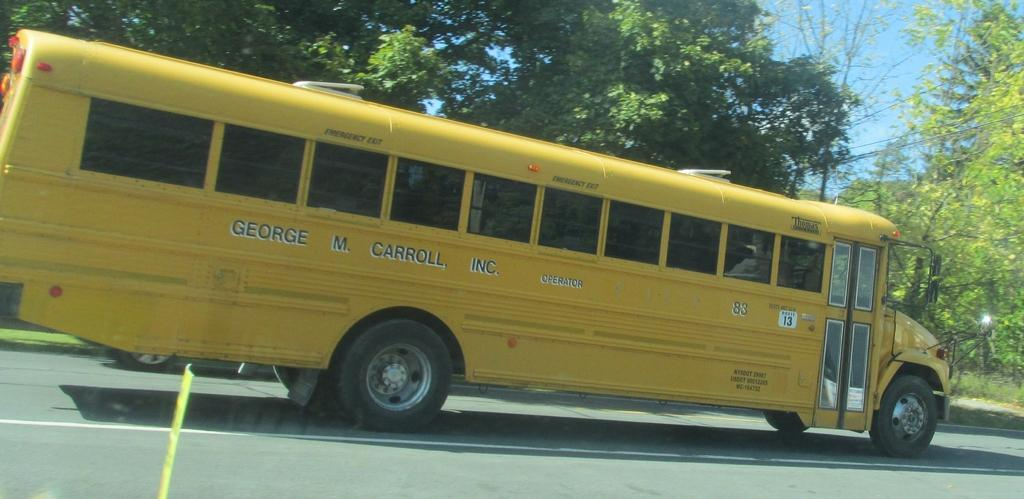What type of vehicle is on the road in the image? There is a motor vehicle on the road in the image. What can be seen in the background of the image? Trees are visible in the image. What else is present in the image besides the motor vehicle and trees? Electric cables are present in the image. What is visible at the top of the image? The sky is visible in the image. Where is the base for the goose located in the image? There is no goose or base present in the image. What type of plate is being used by the motor vehicle in the image? There is no plate visible in the image, as it features a motor vehicle on the road. 